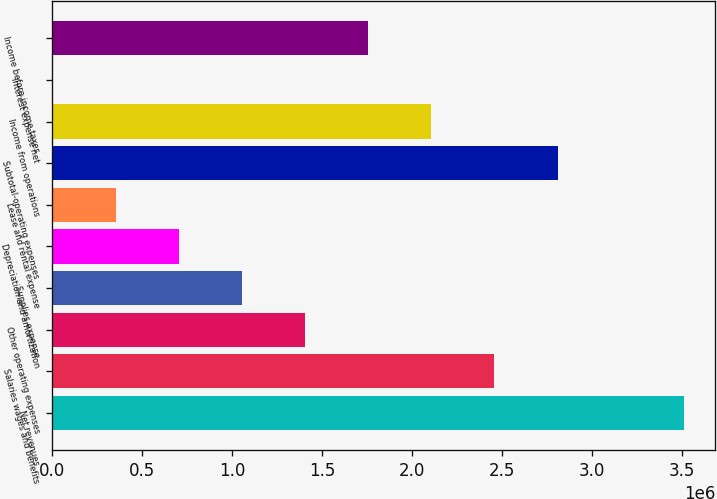Convert chart to OTSL. <chart><loc_0><loc_0><loc_500><loc_500><bar_chart><fcel>Net revenues<fcel>Salaries wages and benefits<fcel>Other operating expenses<fcel>Supplies expense<fcel>Depreciation and amortization<fcel>Lease and rental expense<fcel>Subtotal-operating expenses<fcel>Income from operations<fcel>Interest expense net<fcel>Income before income taxes<nl><fcel>3.50795e+06<fcel>2.45619e+06<fcel>1.40443e+06<fcel>1.05384e+06<fcel>703254<fcel>352666<fcel>2.80678e+06<fcel>2.1056e+06<fcel>2079<fcel>1.75502e+06<nl></chart> 